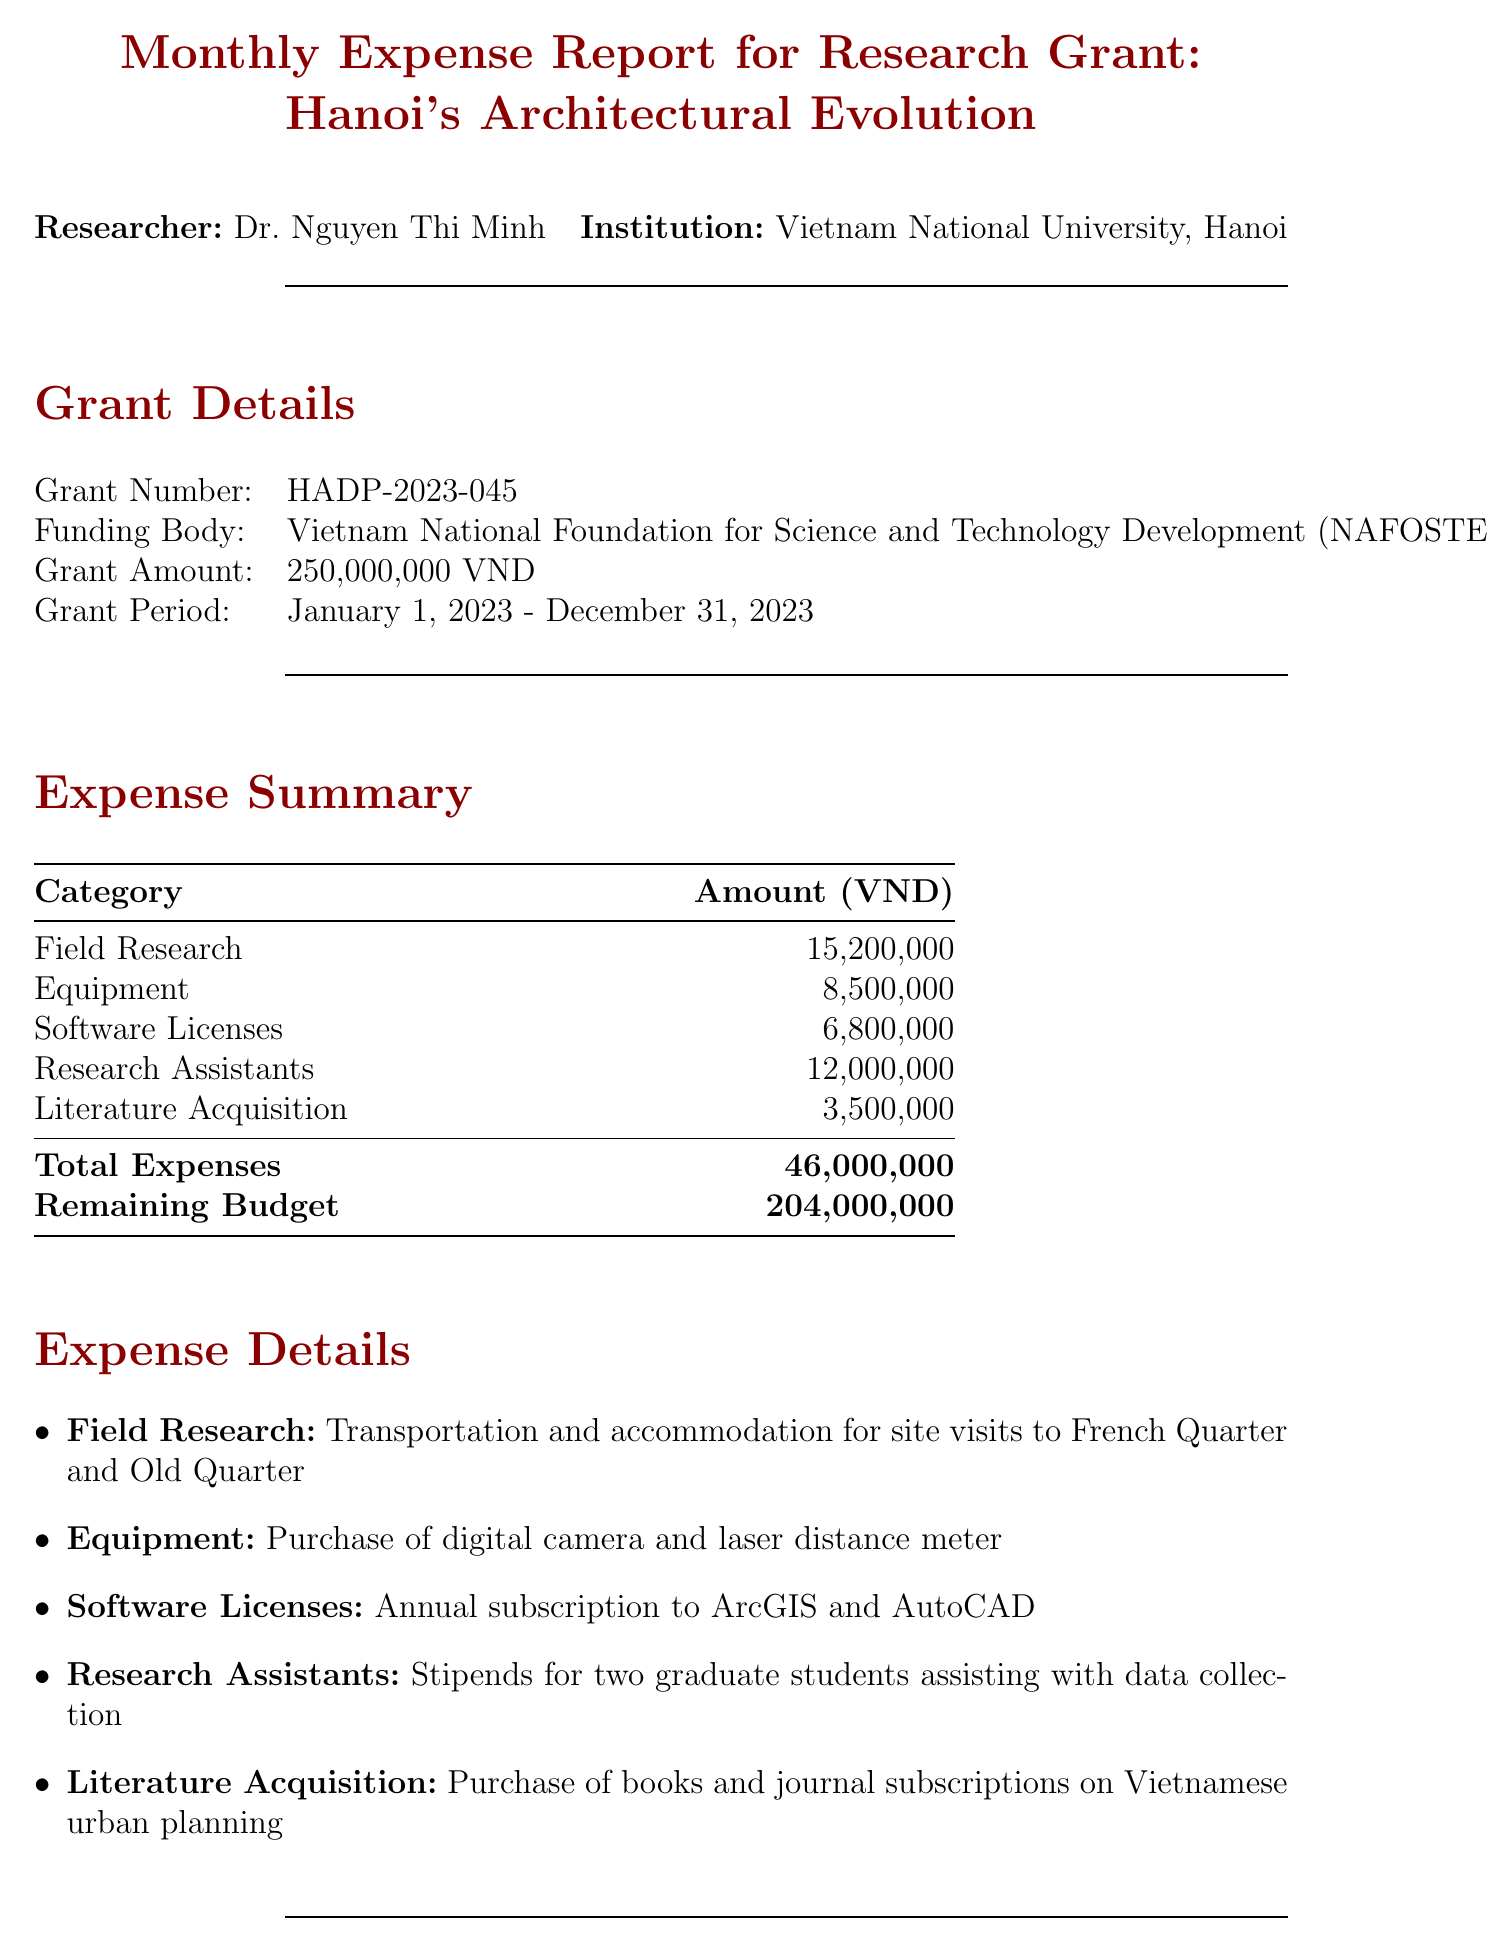What is the grant number? The grant number is mentioned in the grant details section of the report.
Answer: HADP-2023-045 Who is the researcher? The report specifies the name of the researcher at the beginning.
Answer: Dr. Nguyen Thi Minh What is the total amount of expenses? The total expenses are summarized in the expense summary section.
Answer: 46,000,000 VND What is the remaining budget? The remaining budget is calculated after summing up expenses and is stated in the expense summary.
Answer: 204,000,000 VND What is the amount spent on literature acquisition? The amount for literature acquisition is listed under the expense details.
Answer: 3,500,000 VND How many heritage buildings were surveyed? The notable achievements section indicates the number of buildings surveyed.
Answer: 50 What is the main focus for next month? The next month plans section outlines the focus area for upcoming work.
Answer: Analyzing French colonial influence on Hanoi's urban layout Which software licenses were subscribed to? The expense details specify the software licenses purchased for the research.
Answer: ArcGIS and AutoCAD What institution is affiliated with the researcher? The institution associated with the researcher is mentioned at the beginning of the report.
Answer: Vietnam National University, Hanoi 